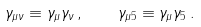Convert formula to latex. <formula><loc_0><loc_0><loc_500><loc_500>\gamma _ { \mu \nu } \equiv \gamma _ { \mu } \gamma _ { \nu } \, , \quad \gamma _ { \mu 5 } \equiv \gamma _ { \mu } \gamma _ { 5 } \, .</formula> 